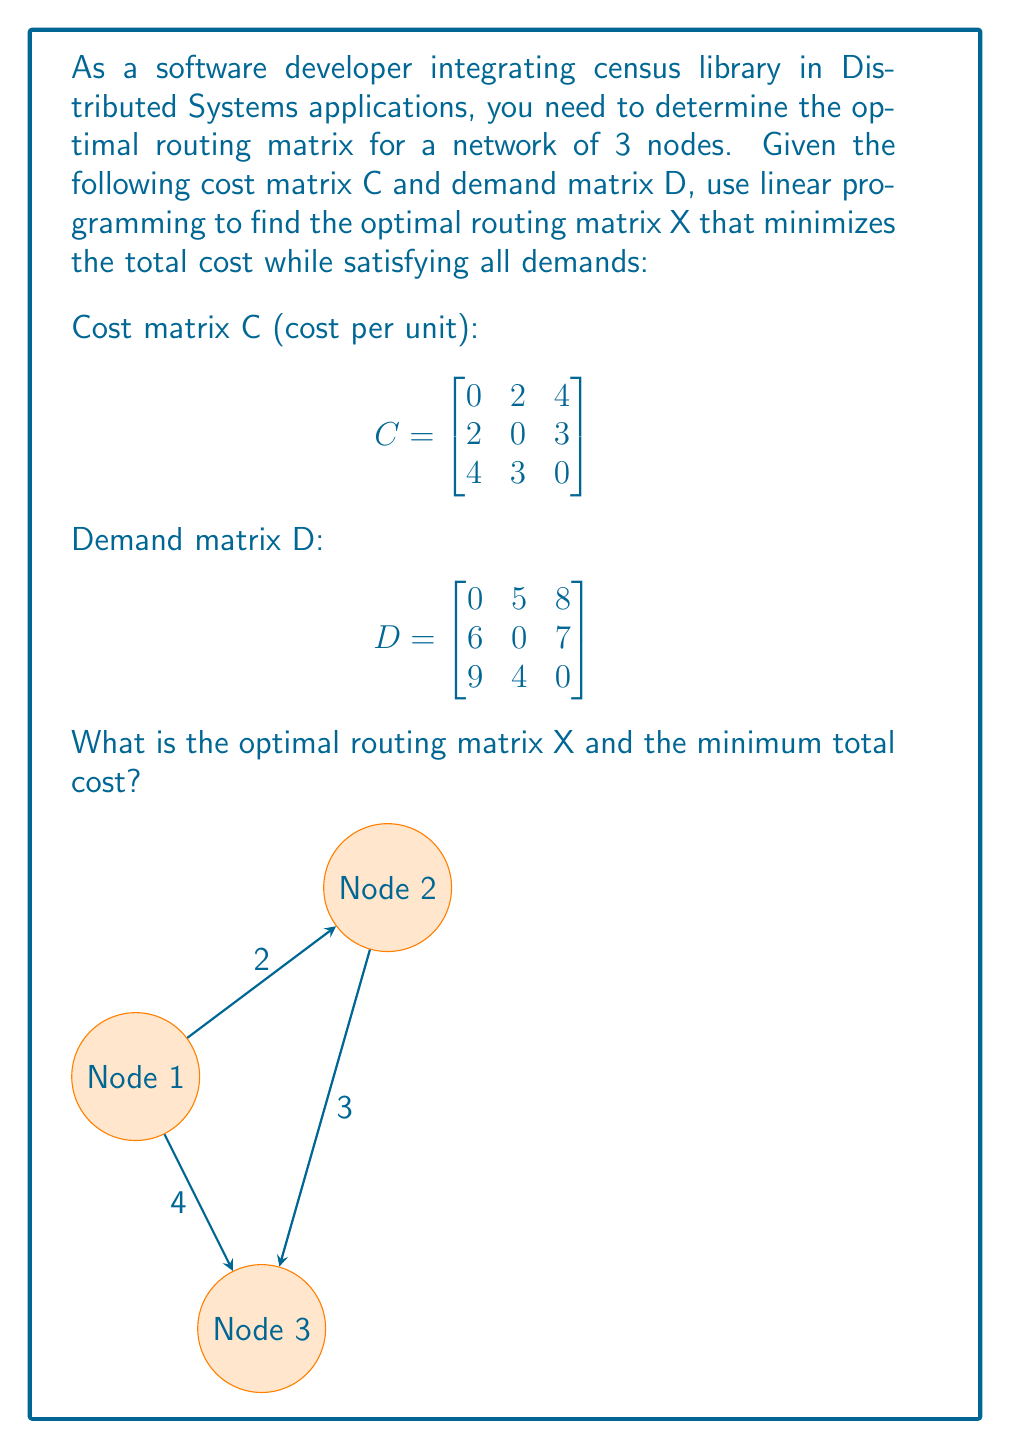Could you help me with this problem? To solve this linear programming problem, we'll follow these steps:

1) Define the decision variables:
   $x_{ij}$ represents the amount of traffic from node i to node j.

2) Formulate the objective function:
   Minimize $Z = \sum_{i=1}^3 \sum_{j=1}^3 c_{ij}x_{ij}$
   
   $Z = 2x_{12} + 4x_{13} + 2x_{21} + 3x_{23} + 4x_{31} + 3x_{32}$

3) Set up the constraints:
   a) Supply constraints:
      $x_{12} + x_{13} = 13$ (Node 1)
      $x_{21} + x_{23} = 13$ (Node 2)
      $x_{31} + x_{32} = 13$ (Node 3)

   b) Demand constraints:
      $x_{21} + x_{31} = 15$ (Node 1)
      $x_{12} + x_{32} = 9$  (Node 2)
      $x_{13} + x_{23} = 15$ (Node 3)

   c) Non-negativity constraints:
      $x_{ij} \geq 0$ for all i, j

4) Solve the linear programming problem using a solver (e.g., simplex method).

5) The optimal solution is:
   $x_{12} = 5, x_{13} = 8, x_{21} = 6, x_{23} = 7, x_{31} = 9, x_{32} = 4$

6) The optimal routing matrix X is:
   $$X = \begin{bmatrix}
   0 & 5 & 8 \\
   6 & 0 & 7 \\
   9 & 4 & 0
   \end{bmatrix}$$

7) Calculate the minimum total cost:
   $Z = 2(5) + 4(8) + 2(6) + 3(7) + 4(9) + 3(4) = 10 + 32 + 12 + 21 + 36 + 12 = 123$

Thus, the optimal routing matrix X is given above, and the minimum total cost is 123 units.
Answer: Optimal routing matrix X = $\begin{bmatrix} 0 & 5 & 8 \\ 6 & 0 & 7 \\ 9 & 4 & 0 \end{bmatrix}$, Minimum total cost = 123 units 